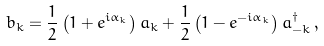<formula> <loc_0><loc_0><loc_500><loc_500>b _ { k } = \frac { 1 } { 2 } \left ( 1 + e ^ { i \alpha _ { k } } \right ) a _ { k } + \frac { 1 } { 2 } \left ( 1 - e ^ { - i \alpha _ { k } } \right ) a ^ { \dagger } _ { - k } \, ,</formula> 